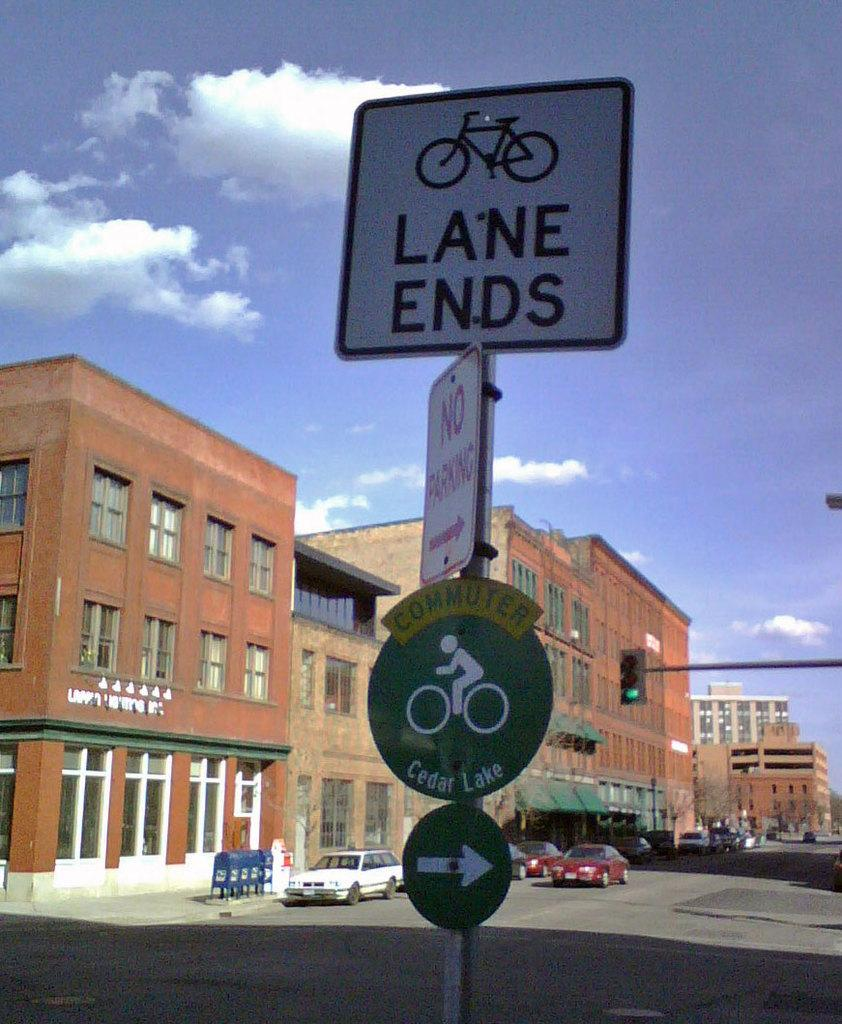<image>
Describe the image concisely. Deserted town with red two door car driving down a street showing a corner with LANE ENDS, NO PARKING and COMMUTER signs. 